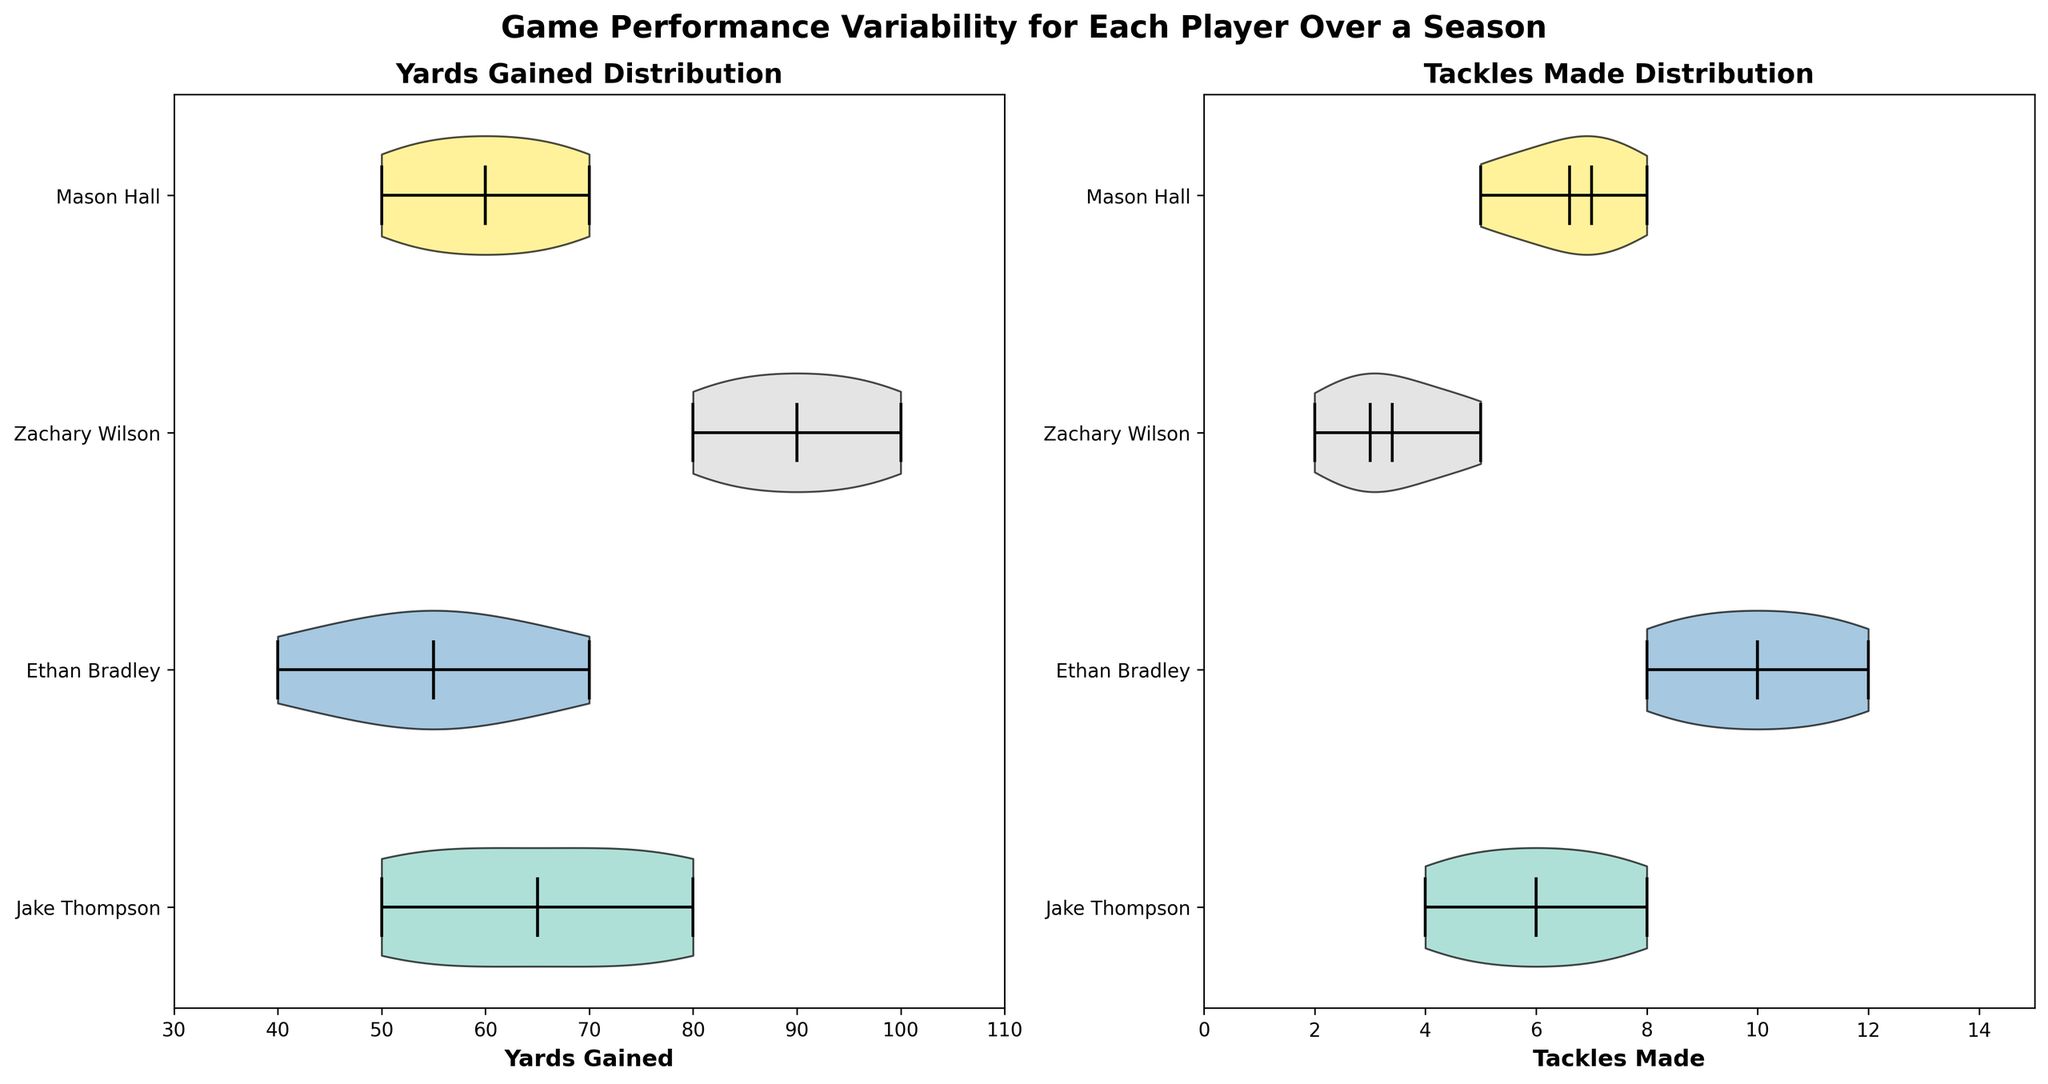Which player has the lowest median yards gained? To find the player with the lowest median yards gained, we look at the horizontal lines in the box within the violins for "Yards Gained". The player with the lowest median (middle line in the box) is Ethan Bradley.
Answer: Ethan Bradley Which player has the highest mean tackles made? The mean is indicated by a white dot in the violin plots for "Tackles Made". Zachary Wilson has the highest white dot, hence the highest mean tackles made.
Answer: Zachary Wilson What's the range of yards gained for Mason Hall? The range can be found by looking at the upper and lower extremes of the violin plot for "Yards Gained" for Mason Hall. The lowest value is around 50 and the highest is around 70. The range is 70 - 50 = 20.
Answer: 20 Between Jake Thompson and Ethan Bradley, who has more consistent yards gained? More consistent performance is indicated by slimmer violins. Comparing the violins for "Yards Gained", Jake Thompson's violin is narrower than Ethan Bradley's, indicating more consistency.
Answer: Jake Thompson What's the overall shape of Zachary Wilson's yards gained distribution? Zachary Wilson's "Yards Gained" violin plot shows a more uniform distribution with a concentration towards the higher end (near 100 yards). This indicates that his performance is fairly consistent at high values.
Answer: Uniform, high-end concentration Who shows wider variability in tackles made, Mason Hall or Jake Thompson? Variability can be assessed by the width of the violin plots for "Tackles Made". Mason Hall's violin is narrower compared to Jake Thompson's violin, implying wider variability for Jake Thompson.
Answer: Jake Thompson Is the mean yards gained for Ethan Bradley higher or lower compared to Jake Thompson? By looking at the position of the white dot (mean indicator) in the "Yards Gained" violin plots, it's evident that Jake Thompson has a higher mean compared to Ethan Bradley.
Answer: Lower Which player has the closest median to the maximum value in tackles made? The maximum value is indicated by the upper extreme line. Comparing the medians (middle line in the box) with the maximum value for each player's "Tackles Made", Ethan Bradley's median is closest to his maximum value.
Answer: Ethan Bradley What can you infer about the consistency of Zachary Wilson's tackles made across the season? Zachary Wilson's "Tackles Made" violin plot is narrower compared to others, indicating he has been consistent in making tackles, with lower variability.
Answer: Consistent Among all players, who has the highest variability in yards gained? The widest violin plot for "Yards Gained" indicates the highest variability. Jake Thompson shows the widest violin for yards gained, indicating the highest variability.
Answer: Jake Thompson 